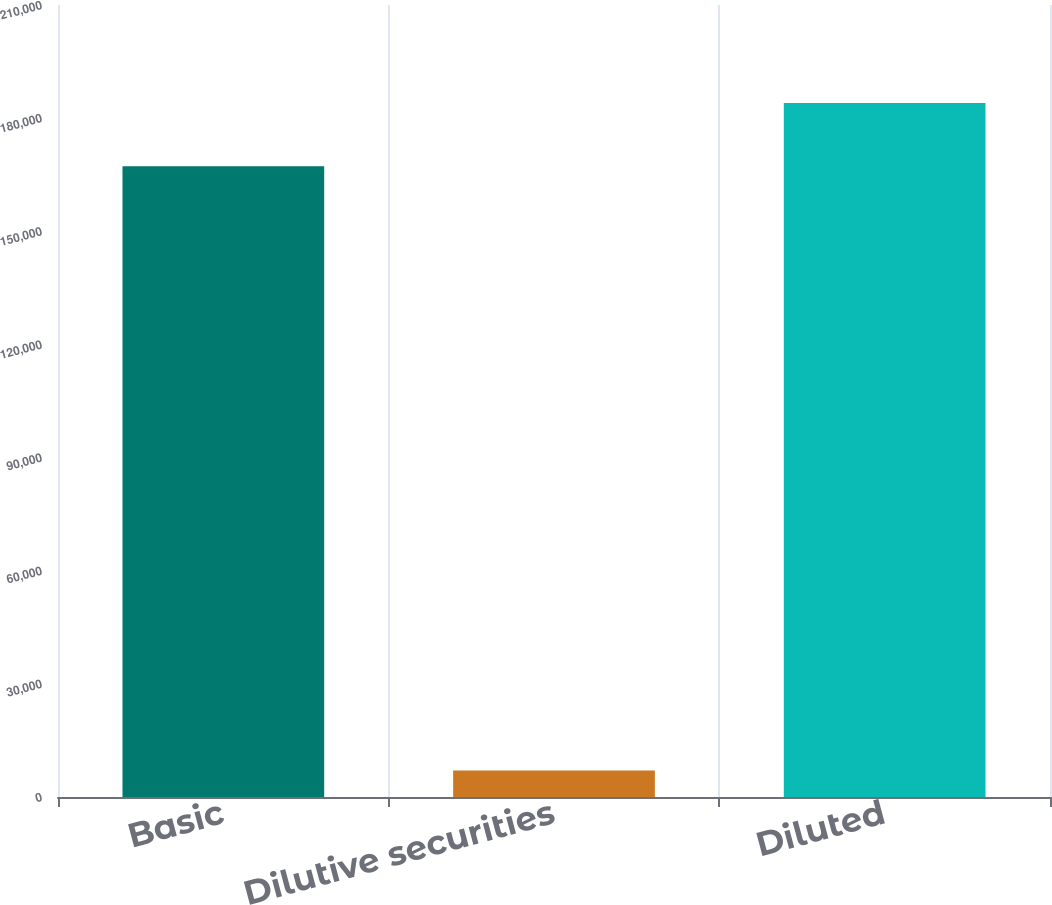Convert chart to OTSL. <chart><loc_0><loc_0><loc_500><loc_500><bar_chart><fcel>Basic<fcel>Dilutive securities<fcel>Diluted<nl><fcel>167257<fcel>7028<fcel>183983<nl></chart> 